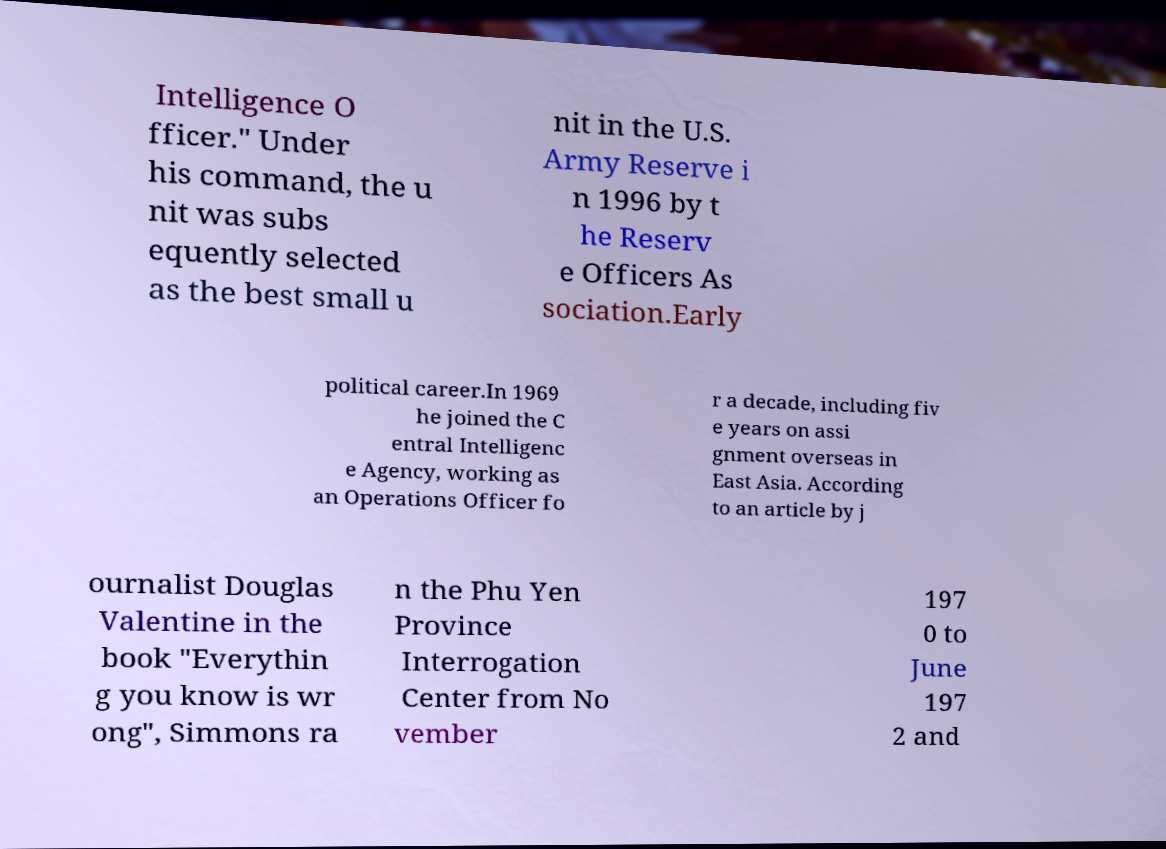Please read and relay the text visible in this image. What does it say? Intelligence O fficer." Under his command, the u nit was subs equently selected as the best small u nit in the U.S. Army Reserve i n 1996 by t he Reserv e Officers As sociation.Early political career.In 1969 he joined the C entral Intelligenc e Agency, working as an Operations Officer fo r a decade, including fiv e years on assi gnment overseas in East Asia. According to an article by j ournalist Douglas Valentine in the book "Everythin g you know is wr ong", Simmons ra n the Phu Yen Province Interrogation Center from No vember 197 0 to June 197 2 and 